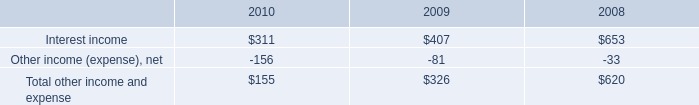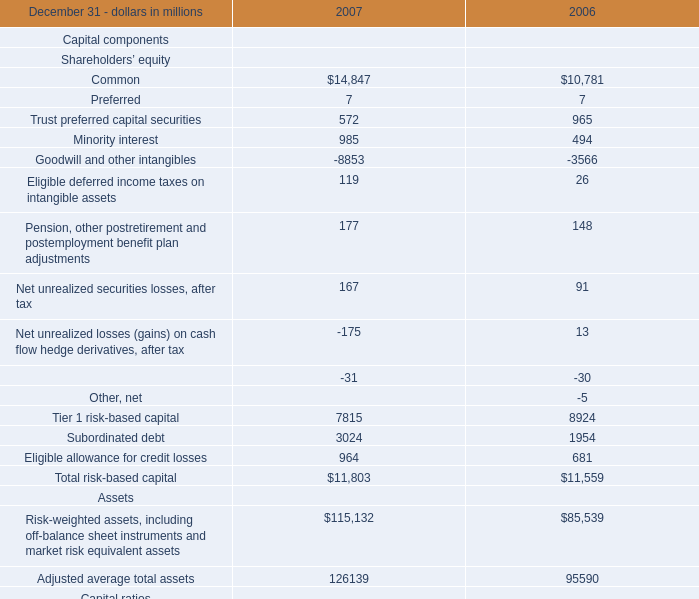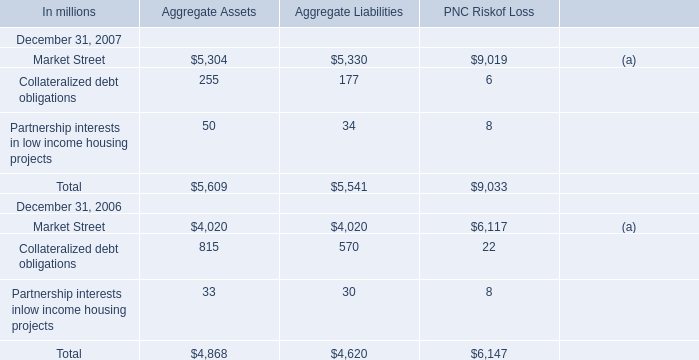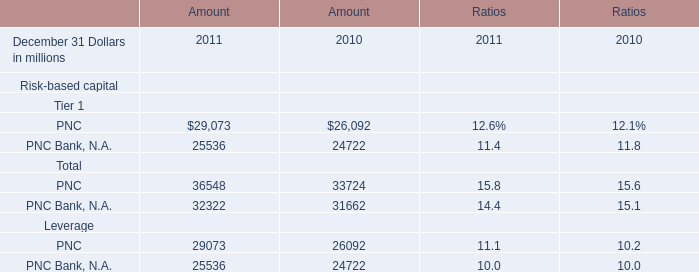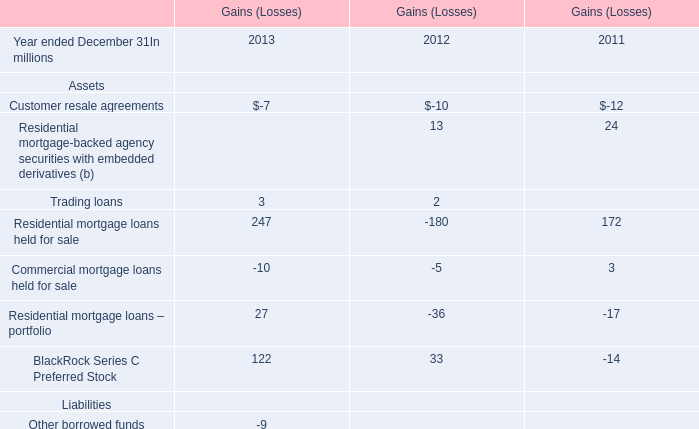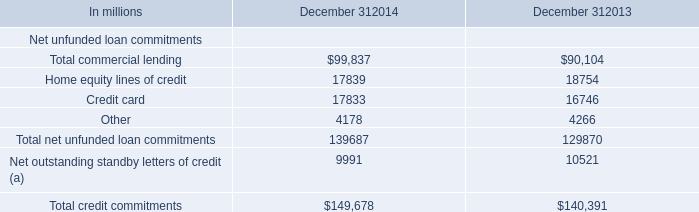As As the chart 1 shows,in what year is the value of Leverage on December 31 the lowest? 
Answer: 2007. 